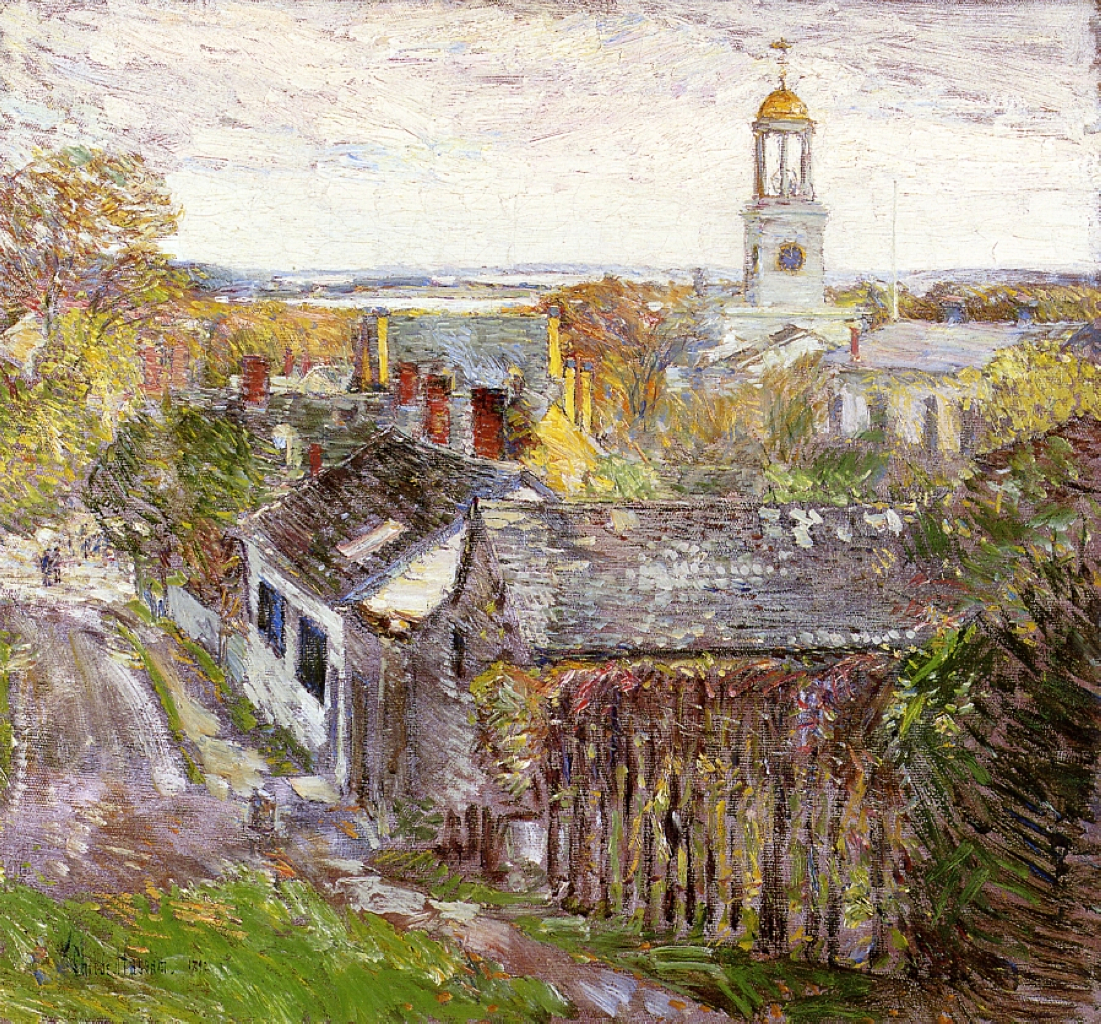Explain the visual content of the image in great detail. The painting, executed in an impressionist style, presents a rustic view of a small town during what appears to be the early autumn. The canvas is alive with a dynamic array of brushstrokes depicting a cobblestone path leading through a cluster of quaint, cottage-like houses with moss-covered roofs and exposed brick chimneys. In the foreground, one dilapidated building, partly covered in ivy, draws particular attention with its faded white walls. The centerpiece of the composition is a stately church, characterized by a striking golden dome that gleams under a soft blue sky speckled with light clouds. The palette is rich with autumnal hues - burnt oranges, muted greens, and splashes of yellow suggesting a canopy of leaves in the transitional phase of the season. The artist's use of light and shadow imaginatively adds depth and mood, making the scene not just a visual experience but an evocative journey into a serene, almost nostalgic pastoral life. 